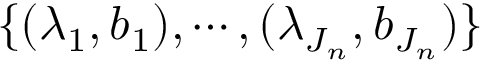<formula> <loc_0><loc_0><loc_500><loc_500>\{ ( \lambda _ { 1 } , b _ { 1 } ) , \cdots , ( \lambda _ { J _ { n } } , b _ { J _ { n } } ) \}</formula> 